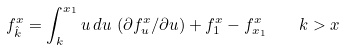<formula> <loc_0><loc_0><loc_500><loc_500>f _ { \hat { k } } ^ { x } = \int _ { k } ^ { x _ { 1 } } u \, d u \, \left ( \partial f _ { u } ^ { x } / \partial u \right ) + f _ { 1 } ^ { x } - f _ { x _ { 1 } } ^ { x } \quad k > x</formula> 